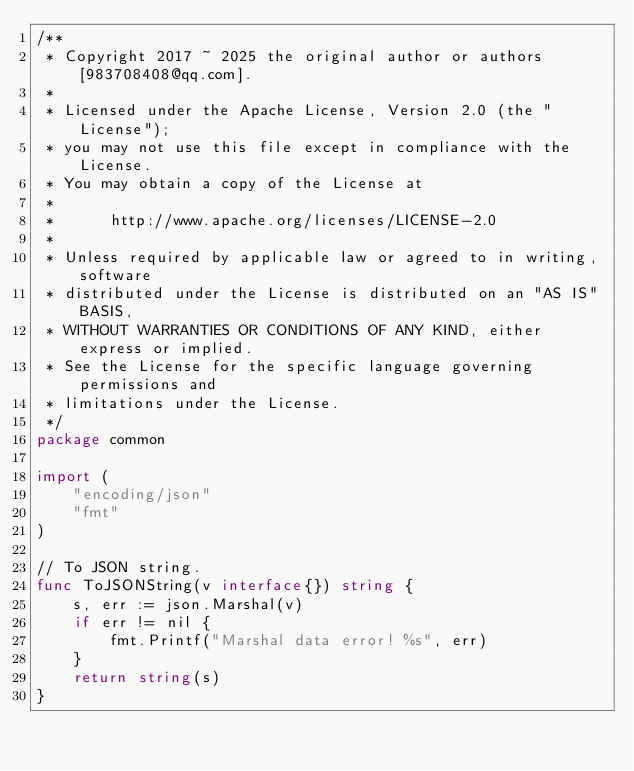Convert code to text. <code><loc_0><loc_0><loc_500><loc_500><_Go_>/**
 * Copyright 2017 ~ 2025 the original author or authors[983708408@qq.com].
 *
 * Licensed under the Apache License, Version 2.0 (the "License");
 * you may not use this file except in compliance with the License.
 * You may obtain a copy of the License at
 *
 *      http://www.apache.org/licenses/LICENSE-2.0
 *
 * Unless required by applicable law or agreed to in writing, software
 * distributed under the License is distributed on an "AS IS" BASIS,
 * WITHOUT WARRANTIES OR CONDITIONS OF ANY KIND, either express or implied.
 * See the License for the specific language governing permissions and
 * limitations under the License.
 */
package common

import (
	"encoding/json"
	"fmt"
)

// To JSON string.
func ToJSONString(v interface{}) string {
	s, err := json.Marshal(v)
	if err != nil {
		fmt.Printf("Marshal data error! %s", err)
	}
	return string(s)
}
</code> 